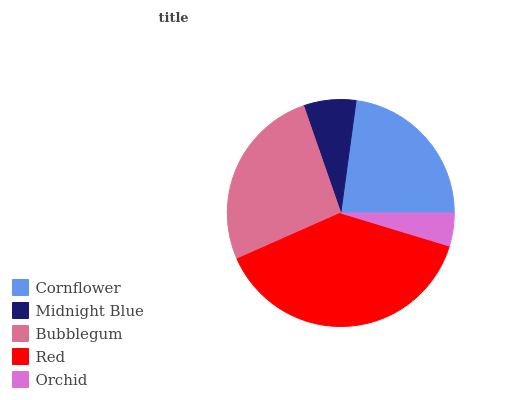Is Orchid the minimum?
Answer yes or no. Yes. Is Red the maximum?
Answer yes or no. Yes. Is Midnight Blue the minimum?
Answer yes or no. No. Is Midnight Blue the maximum?
Answer yes or no. No. Is Cornflower greater than Midnight Blue?
Answer yes or no. Yes. Is Midnight Blue less than Cornflower?
Answer yes or no. Yes. Is Midnight Blue greater than Cornflower?
Answer yes or no. No. Is Cornflower less than Midnight Blue?
Answer yes or no. No. Is Cornflower the high median?
Answer yes or no. Yes. Is Cornflower the low median?
Answer yes or no. Yes. Is Bubblegum the high median?
Answer yes or no. No. Is Bubblegum the low median?
Answer yes or no. No. 